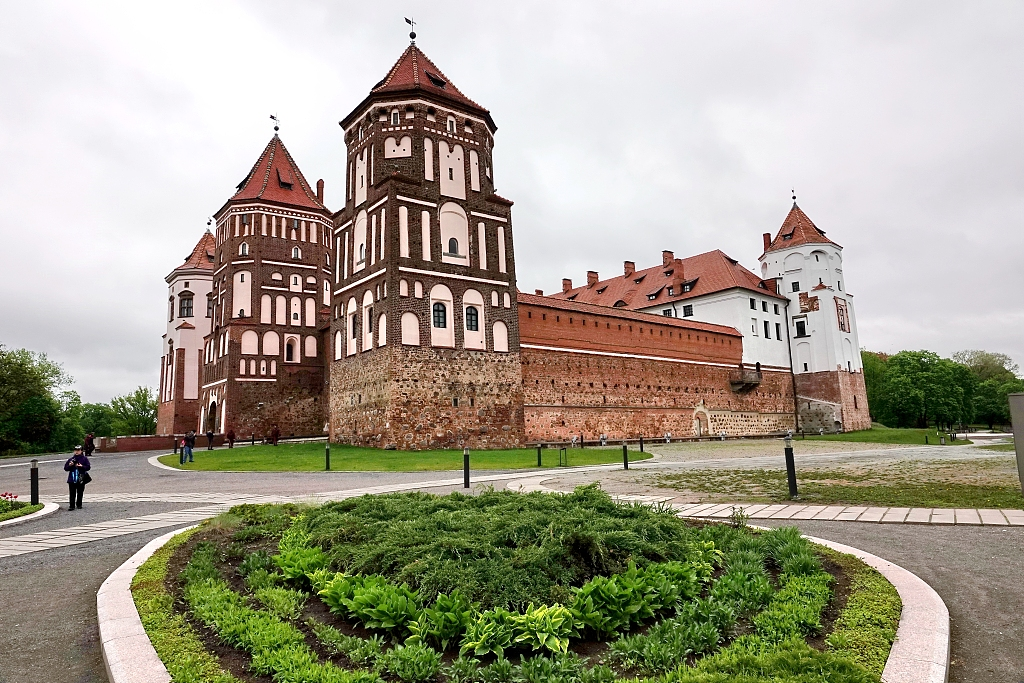Imagine you are a historian who just discovered a hidden room in the castle. What might be inside? As a historian, discovering a hidden room in Mir Castle would be extraordinary. The room, untouched for centuries, might contain ancient manuscripts detailing the castle’s construction, letters between noble families, and maps showcasing territories long forgotten. Priceless artifacts such as antique furniture, ornate chandeliers, and faded tapestries might reside within, telling the tales of the castle’s past inhabitants. Among the treasures, one could find a dusty old chest, filled with gold coins, exquisite jewelry, and relics of historical significance. This hidden repository could offer a wealth of knowledge, shedding new light on the history and mysteries of the Mir Castle Complex.  What kind of secret passages might be hidden within the castle walls? The Mir Castle, with its storied past and majestic architecture, might hold an array of secret passages hidden within its walls. These clandestine corridors were likely designed for strategic advantage, allowing inhabitants to move unseen or escape during sieges. Some passages might lead to hidden chambers used for safekeeping treasures or conducting covert meetings. Others might connect different sections of the castle, enabling discreet movement for the nobility. The walls might conceal narrow staircases spiraling into the depths of the castle, leading to dungeons, wine cellars, or even tunnels extending beyond the castle grounds into the surrounding forests. These hidden pathways would add an element of mystery and intrigue, revealing yet another layer of the castle’s rich history. 